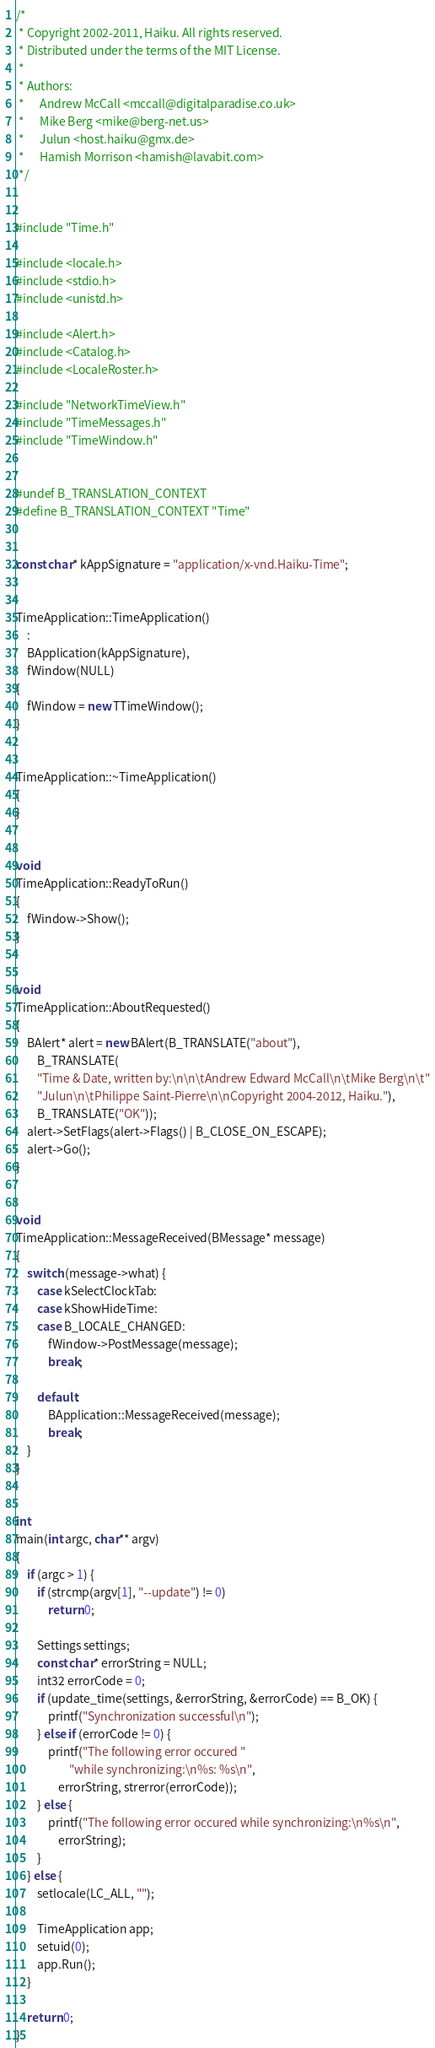Convert code to text. <code><loc_0><loc_0><loc_500><loc_500><_C++_>/*
 * Copyright 2002-2011, Haiku. All rights reserved.
 * Distributed under the terms of the MIT License.
 *
 * Authors:
 *		Andrew McCall <mccall@digitalparadise.co.uk>
 *		Mike Berg <mike@berg-net.us>
 *		Julun <host.haiku@gmx.de>
 *		Hamish Morrison <hamish@lavabit.com>
 */


#include "Time.h"

#include <locale.h>
#include <stdio.h>
#include <unistd.h>

#include <Alert.h>
#include <Catalog.h>
#include <LocaleRoster.h>

#include "NetworkTimeView.h"
#include "TimeMessages.h"
#include "TimeWindow.h"


#undef B_TRANSLATION_CONTEXT
#define B_TRANSLATION_CONTEXT "Time"


const char* kAppSignature = "application/x-vnd.Haiku-Time";


TimeApplication::TimeApplication()
	:
	BApplication(kAppSignature),
	fWindow(NULL)
{
	fWindow = new TTimeWindow();
}


TimeApplication::~TimeApplication()
{
}


void
TimeApplication::ReadyToRun()
{
	fWindow->Show();
}


void
TimeApplication::AboutRequested()
{
	BAlert* alert = new BAlert(B_TRANSLATE("about"),
		B_TRANSLATE(
		"Time & Date, written by:\n\n\tAndrew Edward McCall\n\tMike Berg\n\t"
		"Julun\n\tPhilippe Saint-Pierre\n\nCopyright 2004-2012, Haiku."),
		B_TRANSLATE("OK"));
	alert->SetFlags(alert->Flags() | B_CLOSE_ON_ESCAPE);
	alert->Go();
}


void
TimeApplication::MessageReceived(BMessage* message)
{
	switch (message->what) {
		case kSelectClockTab:
		case kShowHideTime:
		case B_LOCALE_CHANGED:
			fWindow->PostMessage(message);
			break;

		default:
			BApplication::MessageReceived(message);
			break;
	}
}


int
main(int argc, char** argv)
{
	if (argc > 1) {
		if (strcmp(argv[1], "--update") != 0)
			return 0;

		Settings settings;
		const char* errorString = NULL;
		int32 errorCode = 0;
		if (update_time(settings, &errorString, &errorCode) == B_OK) {
			printf("Synchronization successful\n");
		} else if (errorCode != 0) {
			printf("The following error occured "
					"while synchronizing:\n%s: %s\n",
				errorString, strerror(errorCode));
		} else {
			printf("The following error occured while synchronizing:\n%s\n",
				errorString);
		}
	} else {
		setlocale(LC_ALL, "");

		TimeApplication app;
		setuid(0);
		app.Run();
	}

	return 0;
}

</code> 